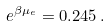<formula> <loc_0><loc_0><loc_500><loc_500>e ^ { \beta \mu _ { e } } = 0 . 2 4 5 \, .</formula> 